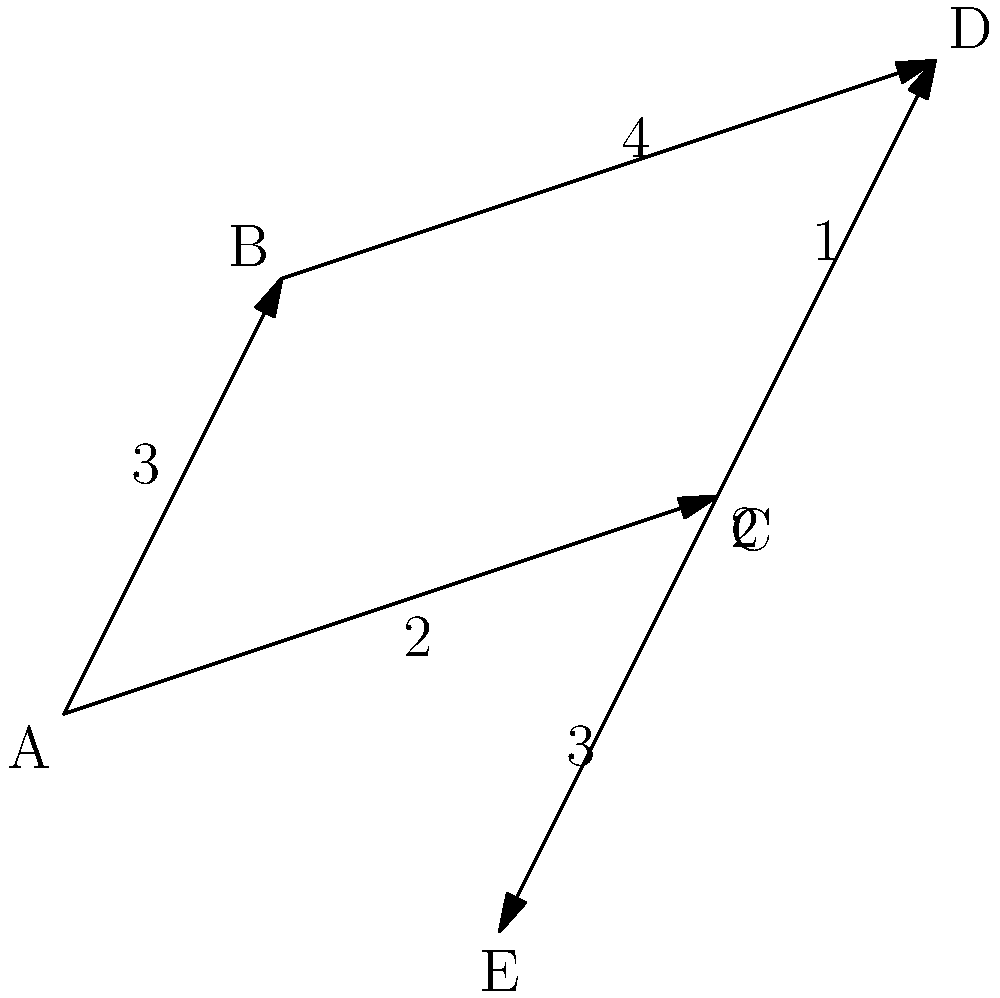In a bustling Asian city, five popular fashion districts are represented as nodes A, B, C, D, and E on a map. The edges between the nodes represent direct routes, with the numbers indicating travel time in minutes. What is the shortest path from district A to district E, and what is the total travel time? To find the shortest path from A to E, we'll use Dijkstra's algorithm:

1. Initialize:
   - Set A's distance to 0 and all others to infinity.
   - Mark all nodes as unvisited.

2. For the current node (starting with A), consider all unvisited neighbors and calculate their tentative distances:
   - A to B: 3 minutes
   - A to C: 2 minutes

3. Mark A as visited. C has the smallest tentative distance, so it becomes the current node.

4. From C, calculate tentative distances:
   - C to D: 2 + 1 = 3 minutes
   - C to E: 2 + 3 = 5 minutes

5. Mark C as visited. D has the smallest tentative distance among unvisited nodes, so it becomes the current node.

6. From D, calculate tentative distance:
   - D to E: 3 + 2 = 5 minutes (This is equal to the current tentative distance through C)

7. Mark D as visited. E is the only unvisited node, so it becomes the current node.

8. All nodes are visited. The algorithm ends.

The shortest path is A → C → D → E, with a total travel time of 5 minutes.
Answer: A → C → D → E, 5 minutes 